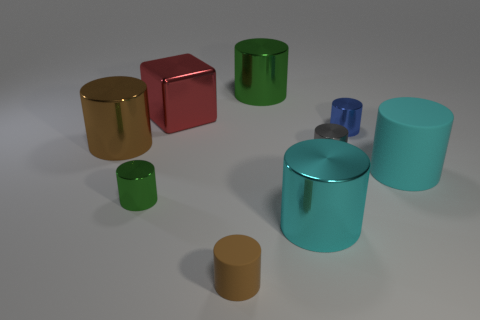Can you describe the color palette present in the image? The image features a harmonious color palette with pastel and metallic shades. There's a mix of warm tones like gold and copper, as well as cooler tones like teal and blue, all complemented by the neutral gray backdrop. 